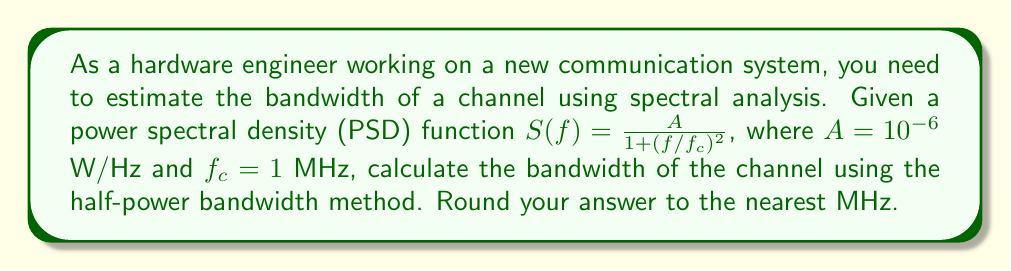Could you help me with this problem? To estimate the bandwidth using the half-power bandwidth method, we need to follow these steps:

1. Find the maximum value of the PSD function:
   At $f = 0$, $S(0) = A = 10^{-6}$ W/Hz

2. Calculate the half-power point:
   Half-power = $S(0)/2 = 5 \times 10^{-7}$ W/Hz

3. Solve for the frequency at which $S(f) = 5 \times 10^{-7}$ W/Hz:

   $$\frac{10^{-6}}{1 + (f/10^6)^2} = 5 \times 10^{-7}$$

4. Simplify and solve for $f$:

   $$\frac{2}{1 + (f/10^6)^2} = 1$$
   $$1 + (f/10^6)^2 = 2$$
   $$(f/10^6)^2 = 1$$
   $$f = 10^6 = 1 \text{ MHz}$$

5. The bandwidth is twice this frequency (since it's measured on both sides of the center frequency):

   Bandwidth = $2f = 2 \times 1 \text{ MHz} = 2 \text{ MHz}$

6. Round to the nearest MHz: 2 MHz
Answer: 2 MHz 